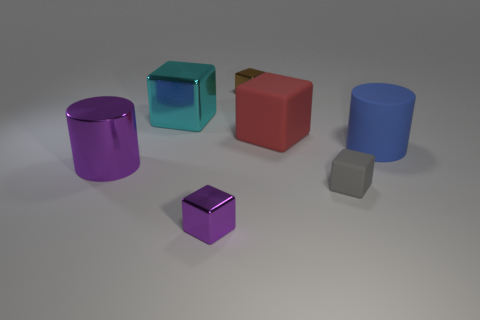Subtract all big cyan cubes. How many cubes are left? 4 Subtract all purple cubes. How many cubes are left? 4 Subtract 2 blocks. How many blocks are left? 3 Subtract all green blocks. Subtract all yellow cylinders. How many blocks are left? 5 Add 1 blue cylinders. How many objects exist? 8 Subtract all cylinders. How many objects are left? 5 Add 5 purple metal cylinders. How many purple metal cylinders are left? 6 Add 2 small brown shiny cubes. How many small brown shiny cubes exist? 3 Subtract 0 red cylinders. How many objects are left? 7 Subtract all tiny shiny cubes. Subtract all metallic cylinders. How many objects are left? 4 